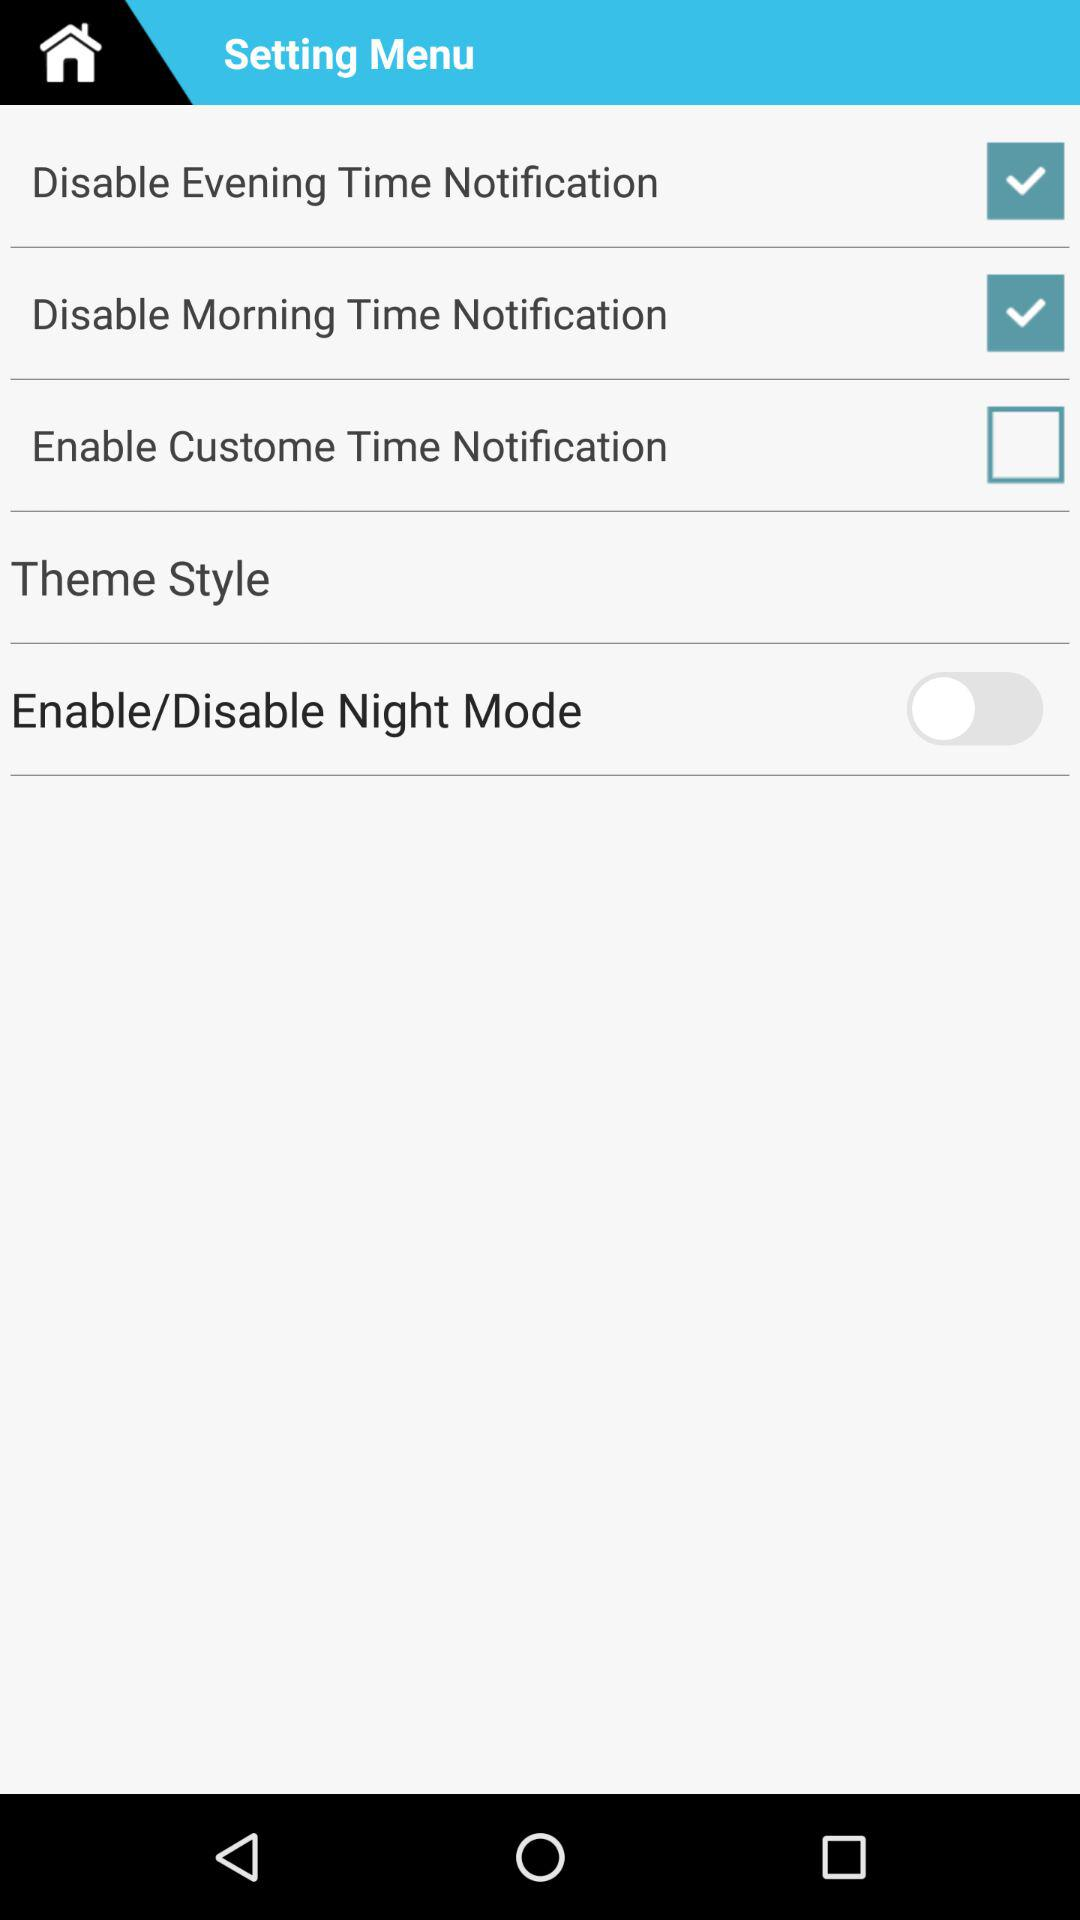Which option is unchecked? The unchecked option is "Enable Custome Time Notification". 